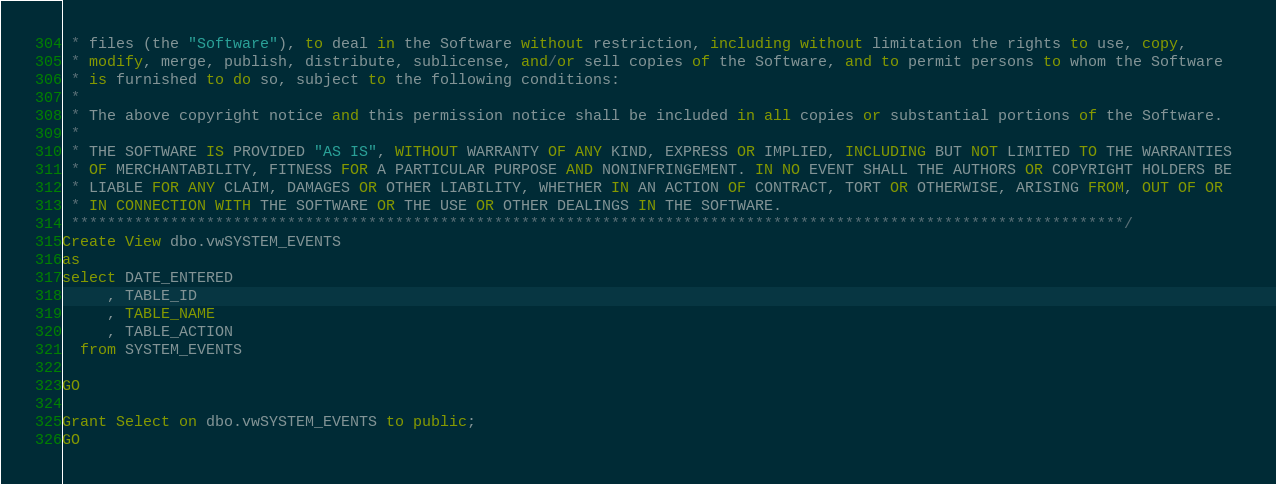<code> <loc_0><loc_0><loc_500><loc_500><_SQL_> * files (the "Software"), to deal in the Software without restriction, including without limitation the rights to use, copy, 
 * modify, merge, publish, distribute, sublicense, and/or sell copies of the Software, and to permit persons to whom the Software 
 * is furnished to do so, subject to the following conditions:
 * 
 * The above copyright notice and this permission notice shall be included in all copies or substantial portions of the Software.
 * 
 * THE SOFTWARE IS PROVIDED "AS IS", WITHOUT WARRANTY OF ANY KIND, EXPRESS OR IMPLIED, INCLUDING BUT NOT LIMITED TO THE WARRANTIES 
 * OF MERCHANTABILITY, FITNESS FOR A PARTICULAR PURPOSE AND NONINFRINGEMENT. IN NO EVENT SHALL THE AUTHORS OR COPYRIGHT HOLDERS BE 
 * LIABLE FOR ANY CLAIM, DAMAGES OR OTHER LIABILITY, WHETHER IN AN ACTION OF CONTRACT, TORT OR OTHERWISE, ARISING FROM, OUT OF OR 
 * IN CONNECTION WITH THE SOFTWARE OR THE USE OR OTHER DEALINGS IN THE SOFTWARE.
 *********************************************************************************************************************/
Create View dbo.vwSYSTEM_EVENTS
as
select DATE_ENTERED
     , TABLE_ID
     , TABLE_NAME
     , TABLE_ACTION
  from SYSTEM_EVENTS

GO

Grant Select on dbo.vwSYSTEM_EVENTS to public;
GO

</code> 